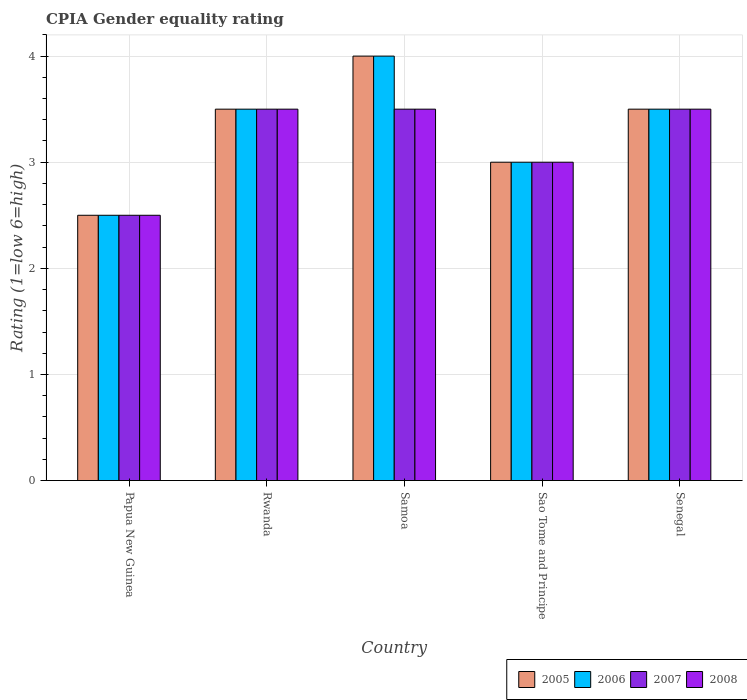How many different coloured bars are there?
Make the answer very short. 4. How many groups of bars are there?
Your answer should be very brief. 5. How many bars are there on the 3rd tick from the left?
Ensure brevity in your answer.  4. How many bars are there on the 5th tick from the right?
Your response must be concise. 4. What is the label of the 5th group of bars from the left?
Your response must be concise. Senegal. In how many cases, is the number of bars for a given country not equal to the number of legend labels?
Provide a succinct answer. 0. In which country was the CPIA rating in 2007 maximum?
Offer a very short reply. Rwanda. In which country was the CPIA rating in 2005 minimum?
Offer a very short reply. Papua New Guinea. What is the total CPIA rating in 2005 in the graph?
Keep it short and to the point. 16.5. What is the difference between the CPIA rating in 2005 in Rwanda and that in Samoa?
Your answer should be very brief. -0.5. What is the ratio of the CPIA rating in 2007 in Papua New Guinea to that in Sao Tome and Principe?
Give a very brief answer. 0.83. Is the CPIA rating in 2005 in Samoa less than that in Sao Tome and Principe?
Offer a very short reply. No. Is the difference between the CPIA rating in 2006 in Papua New Guinea and Sao Tome and Principe greater than the difference between the CPIA rating in 2008 in Papua New Guinea and Sao Tome and Principe?
Provide a short and direct response. No. What is the difference between the highest and the second highest CPIA rating in 2005?
Ensure brevity in your answer.  -0.5. What does the 3rd bar from the right in Sao Tome and Principe represents?
Offer a terse response. 2006. Is it the case that in every country, the sum of the CPIA rating in 2006 and CPIA rating in 2008 is greater than the CPIA rating in 2007?
Provide a succinct answer. Yes. How many countries are there in the graph?
Offer a very short reply. 5. Are the values on the major ticks of Y-axis written in scientific E-notation?
Keep it short and to the point. No. Does the graph contain grids?
Your answer should be very brief. Yes. How are the legend labels stacked?
Ensure brevity in your answer.  Horizontal. What is the title of the graph?
Offer a terse response. CPIA Gender equality rating. Does "1963" appear as one of the legend labels in the graph?
Make the answer very short. No. What is the label or title of the Y-axis?
Make the answer very short. Rating (1=low 6=high). What is the Rating (1=low 6=high) of 2006 in Papua New Guinea?
Your answer should be compact. 2.5. What is the Rating (1=low 6=high) of 2007 in Papua New Guinea?
Your response must be concise. 2.5. What is the Rating (1=low 6=high) in 2007 in Rwanda?
Make the answer very short. 3.5. What is the Rating (1=low 6=high) in 2008 in Rwanda?
Your answer should be compact. 3.5. What is the Rating (1=low 6=high) in 2005 in Samoa?
Make the answer very short. 4. What is the Rating (1=low 6=high) in 2006 in Samoa?
Your response must be concise. 4. What is the Rating (1=low 6=high) of 2005 in Senegal?
Provide a succinct answer. 3.5. What is the Rating (1=low 6=high) in 2008 in Senegal?
Provide a short and direct response. 3.5. Across all countries, what is the maximum Rating (1=low 6=high) of 2005?
Make the answer very short. 4. Across all countries, what is the maximum Rating (1=low 6=high) of 2006?
Keep it short and to the point. 4. Across all countries, what is the maximum Rating (1=low 6=high) of 2008?
Your response must be concise. 3.5. What is the total Rating (1=low 6=high) in 2007 in the graph?
Make the answer very short. 16. What is the difference between the Rating (1=low 6=high) in 2005 in Papua New Guinea and that in Rwanda?
Provide a succinct answer. -1. What is the difference between the Rating (1=low 6=high) of 2006 in Papua New Guinea and that in Rwanda?
Keep it short and to the point. -1. What is the difference between the Rating (1=low 6=high) of 2007 in Papua New Guinea and that in Rwanda?
Offer a terse response. -1. What is the difference between the Rating (1=low 6=high) of 2008 in Papua New Guinea and that in Rwanda?
Offer a very short reply. -1. What is the difference between the Rating (1=low 6=high) in 2008 in Papua New Guinea and that in Samoa?
Your answer should be compact. -1. What is the difference between the Rating (1=low 6=high) of 2005 in Papua New Guinea and that in Sao Tome and Principe?
Your answer should be very brief. -0.5. What is the difference between the Rating (1=low 6=high) in 2006 in Papua New Guinea and that in Sao Tome and Principe?
Your answer should be compact. -0.5. What is the difference between the Rating (1=low 6=high) of 2007 in Papua New Guinea and that in Sao Tome and Principe?
Ensure brevity in your answer.  -0.5. What is the difference between the Rating (1=low 6=high) in 2008 in Papua New Guinea and that in Sao Tome and Principe?
Ensure brevity in your answer.  -0.5. What is the difference between the Rating (1=low 6=high) in 2007 in Papua New Guinea and that in Senegal?
Provide a short and direct response. -1. What is the difference between the Rating (1=low 6=high) in 2006 in Rwanda and that in Samoa?
Your answer should be very brief. -0.5. What is the difference between the Rating (1=low 6=high) of 2007 in Rwanda and that in Samoa?
Give a very brief answer. 0. What is the difference between the Rating (1=low 6=high) in 2007 in Rwanda and that in Senegal?
Offer a very short reply. 0. What is the difference between the Rating (1=low 6=high) of 2008 in Rwanda and that in Senegal?
Give a very brief answer. 0. What is the difference between the Rating (1=low 6=high) of 2005 in Samoa and that in Sao Tome and Principe?
Provide a short and direct response. 1. What is the difference between the Rating (1=low 6=high) of 2007 in Samoa and that in Sao Tome and Principe?
Offer a terse response. 0.5. What is the difference between the Rating (1=low 6=high) of 2008 in Samoa and that in Sao Tome and Principe?
Your answer should be very brief. 0.5. What is the difference between the Rating (1=low 6=high) of 2007 in Samoa and that in Senegal?
Your response must be concise. 0. What is the difference between the Rating (1=low 6=high) of 2008 in Samoa and that in Senegal?
Your answer should be very brief. 0. What is the difference between the Rating (1=low 6=high) of 2005 in Sao Tome and Principe and that in Senegal?
Your answer should be very brief. -0.5. What is the difference between the Rating (1=low 6=high) of 2005 in Papua New Guinea and the Rating (1=low 6=high) of 2006 in Rwanda?
Make the answer very short. -1. What is the difference between the Rating (1=low 6=high) of 2005 in Papua New Guinea and the Rating (1=low 6=high) of 2007 in Rwanda?
Provide a short and direct response. -1. What is the difference between the Rating (1=low 6=high) of 2005 in Papua New Guinea and the Rating (1=low 6=high) of 2008 in Rwanda?
Your answer should be very brief. -1. What is the difference between the Rating (1=low 6=high) of 2006 in Papua New Guinea and the Rating (1=low 6=high) of 2008 in Rwanda?
Offer a very short reply. -1. What is the difference between the Rating (1=low 6=high) in 2005 in Papua New Guinea and the Rating (1=low 6=high) in 2006 in Samoa?
Provide a succinct answer. -1.5. What is the difference between the Rating (1=low 6=high) in 2006 in Papua New Guinea and the Rating (1=low 6=high) in 2007 in Samoa?
Keep it short and to the point. -1. What is the difference between the Rating (1=low 6=high) of 2006 in Papua New Guinea and the Rating (1=low 6=high) of 2008 in Samoa?
Give a very brief answer. -1. What is the difference between the Rating (1=low 6=high) of 2005 in Papua New Guinea and the Rating (1=low 6=high) of 2006 in Sao Tome and Principe?
Give a very brief answer. -0.5. What is the difference between the Rating (1=low 6=high) in 2006 in Papua New Guinea and the Rating (1=low 6=high) in 2008 in Sao Tome and Principe?
Your response must be concise. -0.5. What is the difference between the Rating (1=low 6=high) in 2005 in Papua New Guinea and the Rating (1=low 6=high) in 2007 in Senegal?
Your answer should be compact. -1. What is the difference between the Rating (1=low 6=high) of 2005 in Papua New Guinea and the Rating (1=low 6=high) of 2008 in Senegal?
Make the answer very short. -1. What is the difference between the Rating (1=low 6=high) of 2006 in Papua New Guinea and the Rating (1=low 6=high) of 2007 in Senegal?
Ensure brevity in your answer.  -1. What is the difference between the Rating (1=low 6=high) of 2006 in Papua New Guinea and the Rating (1=low 6=high) of 2008 in Senegal?
Ensure brevity in your answer.  -1. What is the difference between the Rating (1=low 6=high) in 2005 in Rwanda and the Rating (1=low 6=high) in 2006 in Samoa?
Your answer should be very brief. -0.5. What is the difference between the Rating (1=low 6=high) of 2006 in Rwanda and the Rating (1=low 6=high) of 2007 in Samoa?
Your response must be concise. 0. What is the difference between the Rating (1=low 6=high) in 2006 in Rwanda and the Rating (1=low 6=high) in 2008 in Samoa?
Make the answer very short. 0. What is the difference between the Rating (1=low 6=high) in 2005 in Rwanda and the Rating (1=low 6=high) in 2006 in Sao Tome and Principe?
Provide a short and direct response. 0.5. What is the difference between the Rating (1=low 6=high) in 2005 in Rwanda and the Rating (1=low 6=high) in 2007 in Sao Tome and Principe?
Provide a succinct answer. 0.5. What is the difference between the Rating (1=low 6=high) of 2005 in Rwanda and the Rating (1=low 6=high) of 2008 in Sao Tome and Principe?
Make the answer very short. 0.5. What is the difference between the Rating (1=low 6=high) of 2006 in Rwanda and the Rating (1=low 6=high) of 2008 in Sao Tome and Principe?
Make the answer very short. 0.5. What is the difference between the Rating (1=low 6=high) in 2007 in Rwanda and the Rating (1=low 6=high) in 2008 in Sao Tome and Principe?
Offer a terse response. 0.5. What is the difference between the Rating (1=low 6=high) in 2005 in Rwanda and the Rating (1=low 6=high) in 2007 in Senegal?
Give a very brief answer. 0. What is the difference between the Rating (1=low 6=high) of 2006 in Rwanda and the Rating (1=low 6=high) of 2007 in Senegal?
Offer a very short reply. 0. What is the difference between the Rating (1=low 6=high) of 2006 in Rwanda and the Rating (1=low 6=high) of 2008 in Senegal?
Make the answer very short. 0. What is the difference between the Rating (1=low 6=high) in 2007 in Rwanda and the Rating (1=low 6=high) in 2008 in Senegal?
Make the answer very short. 0. What is the difference between the Rating (1=low 6=high) in 2005 in Samoa and the Rating (1=low 6=high) in 2006 in Sao Tome and Principe?
Make the answer very short. 1. What is the difference between the Rating (1=low 6=high) in 2005 in Samoa and the Rating (1=low 6=high) in 2007 in Sao Tome and Principe?
Keep it short and to the point. 1. What is the difference between the Rating (1=low 6=high) in 2005 in Samoa and the Rating (1=low 6=high) in 2008 in Sao Tome and Principe?
Your response must be concise. 1. What is the difference between the Rating (1=low 6=high) of 2006 in Samoa and the Rating (1=low 6=high) of 2007 in Sao Tome and Principe?
Make the answer very short. 1. What is the difference between the Rating (1=low 6=high) in 2007 in Samoa and the Rating (1=low 6=high) in 2008 in Sao Tome and Principe?
Your answer should be compact. 0.5. What is the difference between the Rating (1=low 6=high) in 2005 in Samoa and the Rating (1=low 6=high) in 2007 in Senegal?
Your answer should be very brief. 0.5. What is the difference between the Rating (1=low 6=high) of 2006 in Samoa and the Rating (1=low 6=high) of 2007 in Senegal?
Offer a very short reply. 0.5. What is the difference between the Rating (1=low 6=high) in 2006 in Samoa and the Rating (1=low 6=high) in 2008 in Senegal?
Make the answer very short. 0.5. What is the difference between the Rating (1=low 6=high) in 2006 in Sao Tome and Principe and the Rating (1=low 6=high) in 2007 in Senegal?
Keep it short and to the point. -0.5. What is the difference between the Rating (1=low 6=high) in 2006 in Sao Tome and Principe and the Rating (1=low 6=high) in 2008 in Senegal?
Provide a succinct answer. -0.5. What is the difference between the Rating (1=low 6=high) of 2007 in Sao Tome and Principe and the Rating (1=low 6=high) of 2008 in Senegal?
Offer a terse response. -0.5. What is the average Rating (1=low 6=high) in 2007 per country?
Make the answer very short. 3.2. What is the average Rating (1=low 6=high) in 2008 per country?
Provide a short and direct response. 3.2. What is the difference between the Rating (1=low 6=high) in 2006 and Rating (1=low 6=high) in 2007 in Papua New Guinea?
Provide a short and direct response. 0. What is the difference between the Rating (1=low 6=high) of 2007 and Rating (1=low 6=high) of 2008 in Papua New Guinea?
Provide a short and direct response. 0. What is the difference between the Rating (1=low 6=high) in 2005 and Rating (1=low 6=high) in 2006 in Rwanda?
Give a very brief answer. 0. What is the difference between the Rating (1=low 6=high) in 2005 and Rating (1=low 6=high) in 2007 in Rwanda?
Ensure brevity in your answer.  0. What is the difference between the Rating (1=low 6=high) in 2007 and Rating (1=low 6=high) in 2008 in Rwanda?
Provide a succinct answer. 0. What is the difference between the Rating (1=low 6=high) of 2005 and Rating (1=low 6=high) of 2006 in Samoa?
Your answer should be compact. 0. What is the difference between the Rating (1=low 6=high) of 2005 and Rating (1=low 6=high) of 2007 in Samoa?
Offer a terse response. 0.5. What is the difference between the Rating (1=low 6=high) in 2005 and Rating (1=low 6=high) in 2008 in Samoa?
Provide a succinct answer. 0.5. What is the difference between the Rating (1=low 6=high) of 2006 and Rating (1=low 6=high) of 2007 in Samoa?
Provide a succinct answer. 0.5. What is the difference between the Rating (1=low 6=high) of 2006 and Rating (1=low 6=high) of 2008 in Samoa?
Provide a short and direct response. 0.5. What is the difference between the Rating (1=low 6=high) of 2005 and Rating (1=low 6=high) of 2006 in Sao Tome and Principe?
Provide a short and direct response. 0. What is the difference between the Rating (1=low 6=high) of 2006 and Rating (1=low 6=high) of 2008 in Sao Tome and Principe?
Provide a short and direct response. 0. What is the difference between the Rating (1=low 6=high) in 2007 and Rating (1=low 6=high) in 2008 in Sao Tome and Principe?
Make the answer very short. 0. What is the difference between the Rating (1=low 6=high) of 2005 and Rating (1=low 6=high) of 2007 in Senegal?
Offer a very short reply. 0. What is the difference between the Rating (1=low 6=high) in 2006 and Rating (1=low 6=high) in 2007 in Senegal?
Your answer should be very brief. 0. What is the difference between the Rating (1=low 6=high) of 2006 and Rating (1=low 6=high) of 2008 in Senegal?
Your answer should be very brief. 0. What is the ratio of the Rating (1=low 6=high) of 2007 in Papua New Guinea to that in Rwanda?
Your response must be concise. 0.71. What is the ratio of the Rating (1=low 6=high) of 2008 in Papua New Guinea to that in Rwanda?
Your answer should be very brief. 0.71. What is the ratio of the Rating (1=low 6=high) of 2006 in Papua New Guinea to that in Samoa?
Ensure brevity in your answer.  0.62. What is the ratio of the Rating (1=low 6=high) of 2007 in Papua New Guinea to that in Samoa?
Your response must be concise. 0.71. What is the ratio of the Rating (1=low 6=high) in 2005 in Papua New Guinea to that in Sao Tome and Principe?
Ensure brevity in your answer.  0.83. What is the ratio of the Rating (1=low 6=high) in 2006 in Papua New Guinea to that in Sao Tome and Principe?
Your response must be concise. 0.83. What is the ratio of the Rating (1=low 6=high) of 2007 in Papua New Guinea to that in Sao Tome and Principe?
Your answer should be compact. 0.83. What is the ratio of the Rating (1=low 6=high) of 2005 in Papua New Guinea to that in Senegal?
Your response must be concise. 0.71. What is the ratio of the Rating (1=low 6=high) in 2006 in Rwanda to that in Samoa?
Your answer should be very brief. 0.88. What is the ratio of the Rating (1=low 6=high) of 2006 in Rwanda to that in Sao Tome and Principe?
Provide a succinct answer. 1.17. What is the ratio of the Rating (1=low 6=high) of 2007 in Rwanda to that in Sao Tome and Principe?
Keep it short and to the point. 1.17. What is the ratio of the Rating (1=low 6=high) of 2008 in Rwanda to that in Sao Tome and Principe?
Your answer should be compact. 1.17. What is the ratio of the Rating (1=low 6=high) in 2008 in Rwanda to that in Senegal?
Make the answer very short. 1. What is the ratio of the Rating (1=low 6=high) in 2005 in Samoa to that in Sao Tome and Principe?
Provide a short and direct response. 1.33. What is the ratio of the Rating (1=low 6=high) in 2006 in Samoa to that in Sao Tome and Principe?
Your response must be concise. 1.33. What is the ratio of the Rating (1=low 6=high) of 2008 in Samoa to that in Sao Tome and Principe?
Your response must be concise. 1.17. What is the ratio of the Rating (1=low 6=high) in 2008 in Samoa to that in Senegal?
Your answer should be very brief. 1. What is the ratio of the Rating (1=low 6=high) of 2007 in Sao Tome and Principe to that in Senegal?
Provide a succinct answer. 0.86. What is the difference between the highest and the second highest Rating (1=low 6=high) of 2006?
Your answer should be compact. 0.5. What is the difference between the highest and the second highest Rating (1=low 6=high) in 2008?
Make the answer very short. 0. What is the difference between the highest and the lowest Rating (1=low 6=high) in 2005?
Provide a succinct answer. 1.5. What is the difference between the highest and the lowest Rating (1=low 6=high) in 2006?
Ensure brevity in your answer.  1.5. What is the difference between the highest and the lowest Rating (1=low 6=high) of 2008?
Offer a very short reply. 1. 